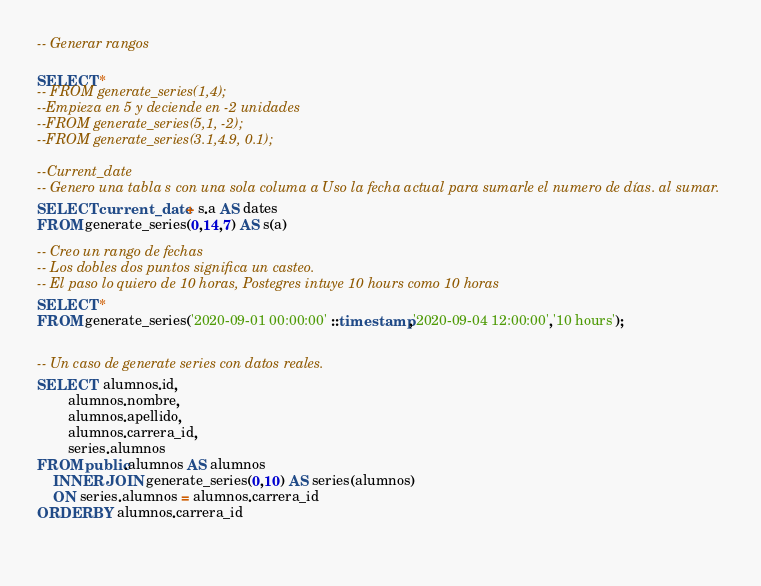Convert code to text. <code><loc_0><loc_0><loc_500><loc_500><_SQL_>-- Generar rangos

SELECT *
-- FROM generate_series(1,4);
--Empieza en 5 y deciende en -2 unidades
--FROM generate_series(5,1, -2);
--FROM generate_series(3.1,4.9, 0.1);

--Current_date
-- Genero una tabla s con una sola columa a Uso la fecha actual para sumarle el numero de días. al sumar.
SELECT current_date + s.a AS dates
FROM generate_series(0,14,7) AS s(a)

-- Creo un rango de fechas
-- Los dobles dos puntos significa un casteo.
-- El paso lo quiero de 10 horas, Postegres intuye 10 hours como 10 horas
SELECT *
FROM generate_series('2020-09-01 00:00:00' ::timestamp,'2020-09-04 12:00:00','10 hours');


-- Un caso de generate series con datos reales.
SELECT  alumnos.id,
		alumnos.nombre,
		alumnos.apellido,
		alumnos.carrera_id,
		series.alumnos
FROM public.alumnos AS alumnos
	INNER JOIN generate_series(0,10) AS series(alumnos)
	ON series.alumnos = alumnos.carrera_id
ORDER BY alumnos.carrera_id	
		
		</code> 